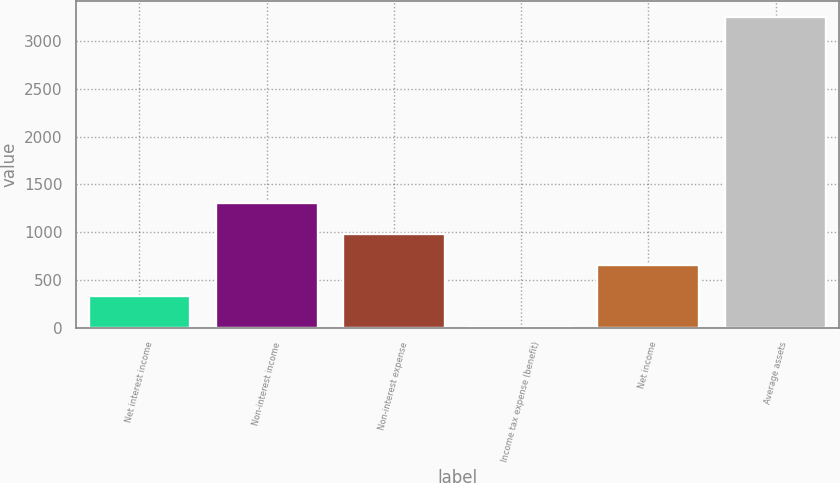Convert chart to OTSL. <chart><loc_0><loc_0><loc_500><loc_500><bar_chart><fcel>Net interest income<fcel>Non-interest income<fcel>Non-interest expense<fcel>Income tax expense (benefit)<fcel>Net income<fcel>Average assets<nl><fcel>329<fcel>1304<fcel>979<fcel>4<fcel>654<fcel>3254<nl></chart> 